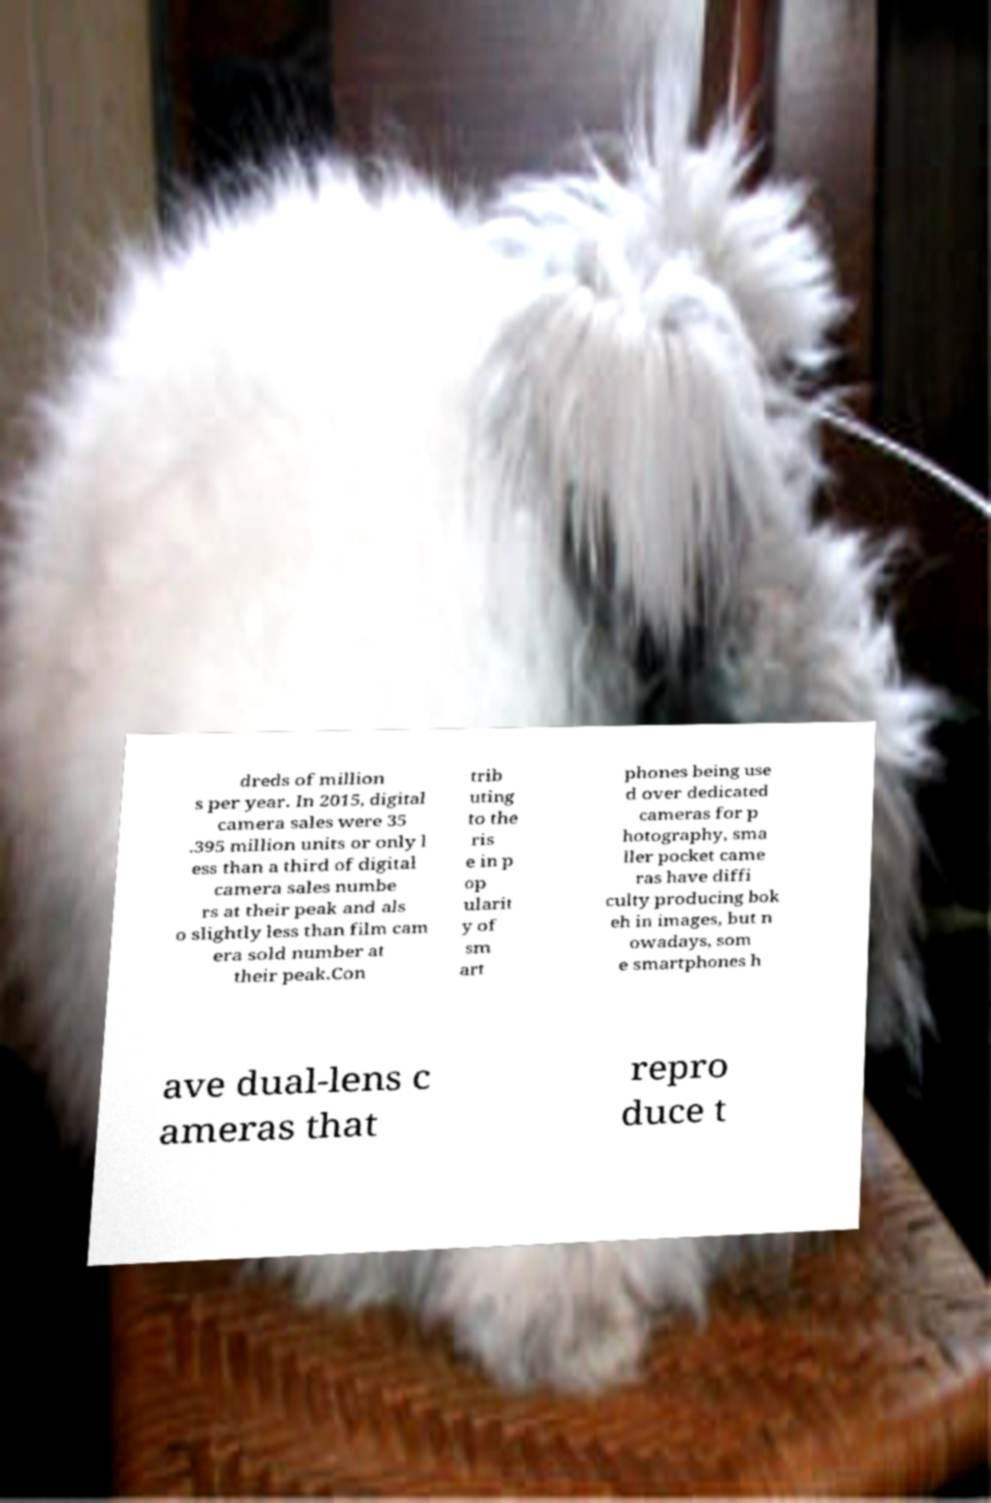There's text embedded in this image that I need extracted. Can you transcribe it verbatim? dreds of million s per year. In 2015, digital camera sales were 35 .395 million units or only l ess than a third of digital camera sales numbe rs at their peak and als o slightly less than film cam era sold number at their peak.Con trib uting to the ris e in p op ularit y of sm art phones being use d over dedicated cameras for p hotography, sma ller pocket came ras have diffi culty producing bok eh in images, but n owadays, som e smartphones h ave dual-lens c ameras that repro duce t 